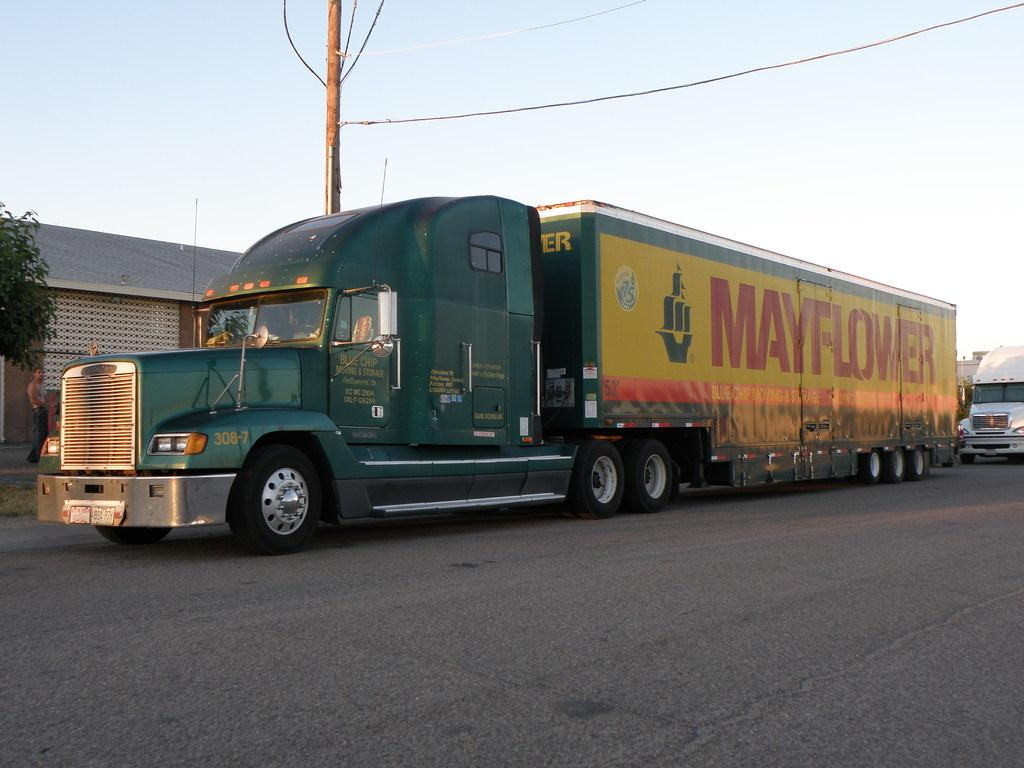What can be seen on the road in the image? There are vehicles parked on the road in the image. What is visible behind the parked vehicles? There is a building visible behind the parked vehicles. What else can be seen in the image besides the parked vehicles and building? There is an electrical wire pole in the image. Where is the playground located in the image? There is no playground present in the image. What type of discussion is taking place in the image? There is no discussion taking place in the image. 